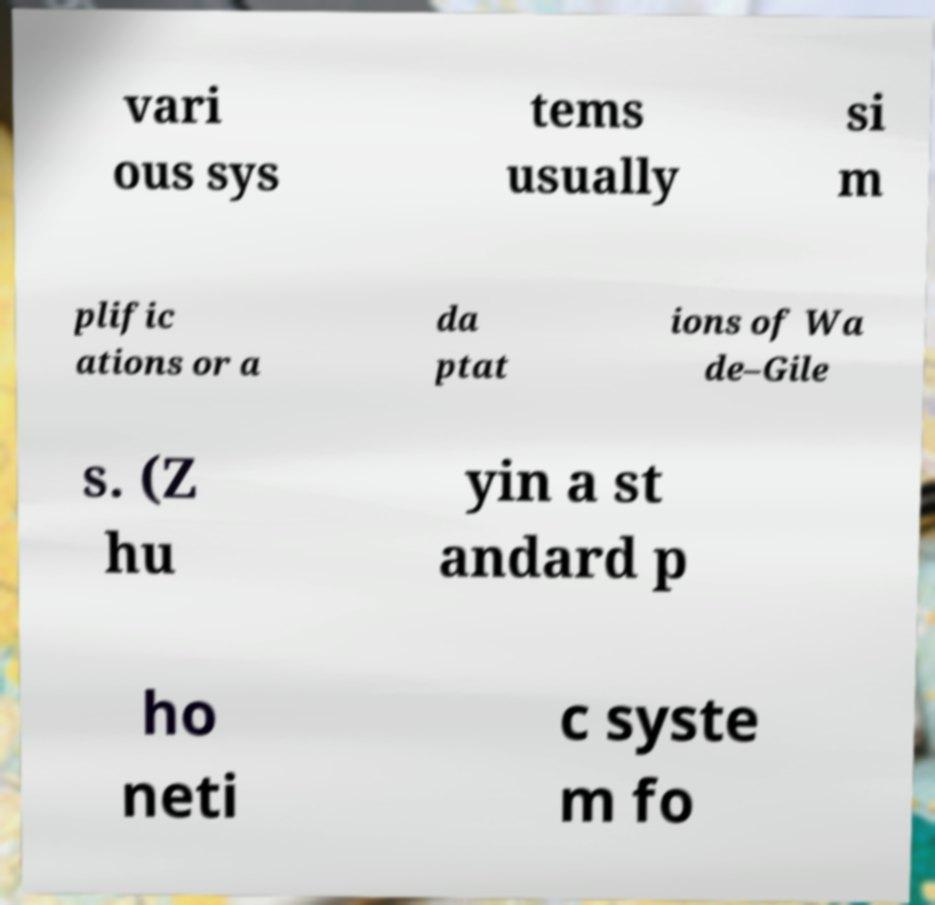Could you assist in decoding the text presented in this image and type it out clearly? vari ous sys tems usually si m plific ations or a da ptat ions of Wa de–Gile s. (Z hu yin a st andard p ho neti c syste m fo 